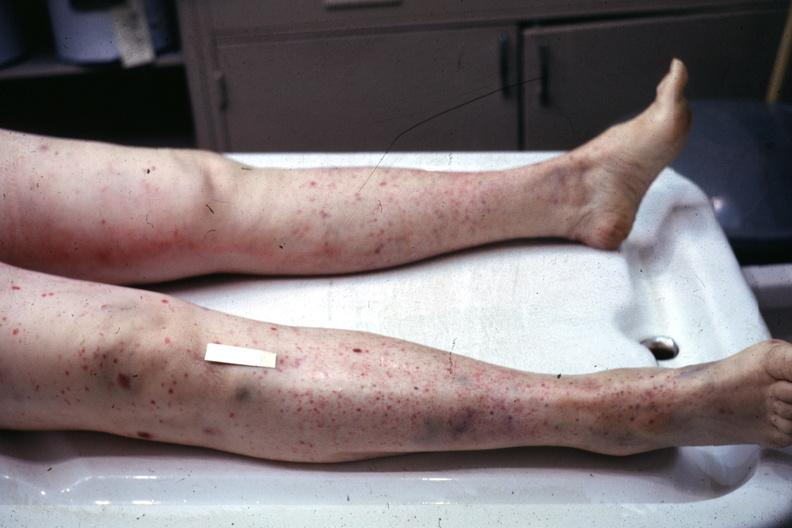does this image show ok but not close enough petechiae?
Answer the question using a single word or phrase. Yes 